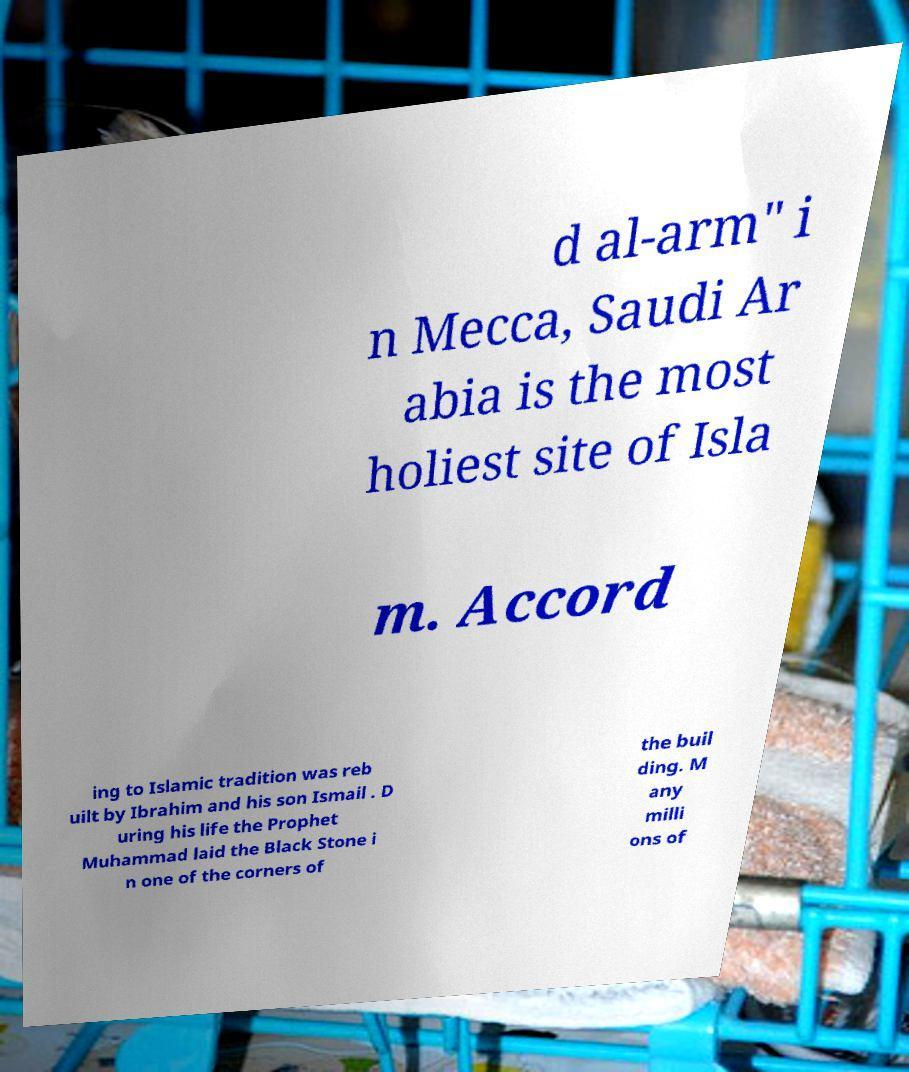Could you extract and type out the text from this image? d al-arm" i n Mecca, Saudi Ar abia is the most holiest site of Isla m. Accord ing to Islamic tradition was reb uilt by Ibrahim and his son Ismail . D uring his life the Prophet Muhammad laid the Black Stone i n one of the corners of the buil ding. M any milli ons of 